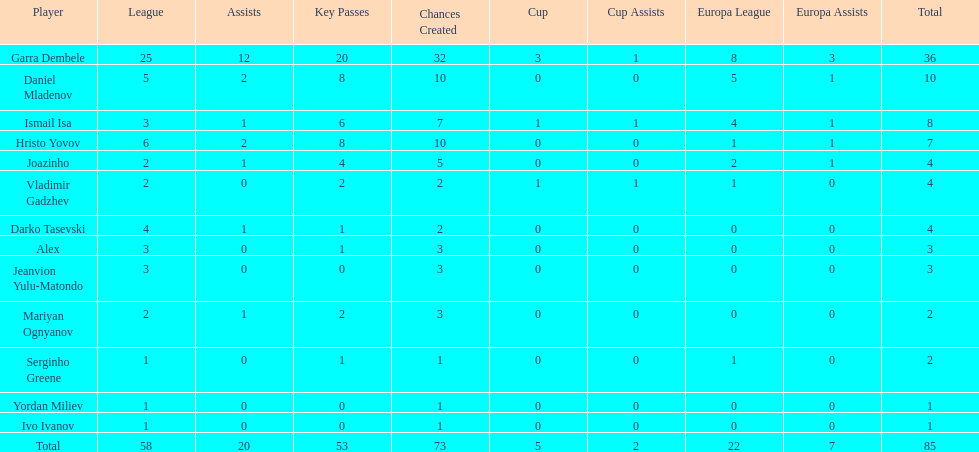Which player is in the same league as joazinho and vladimir gadzhev? Mariyan Ognyanov. 